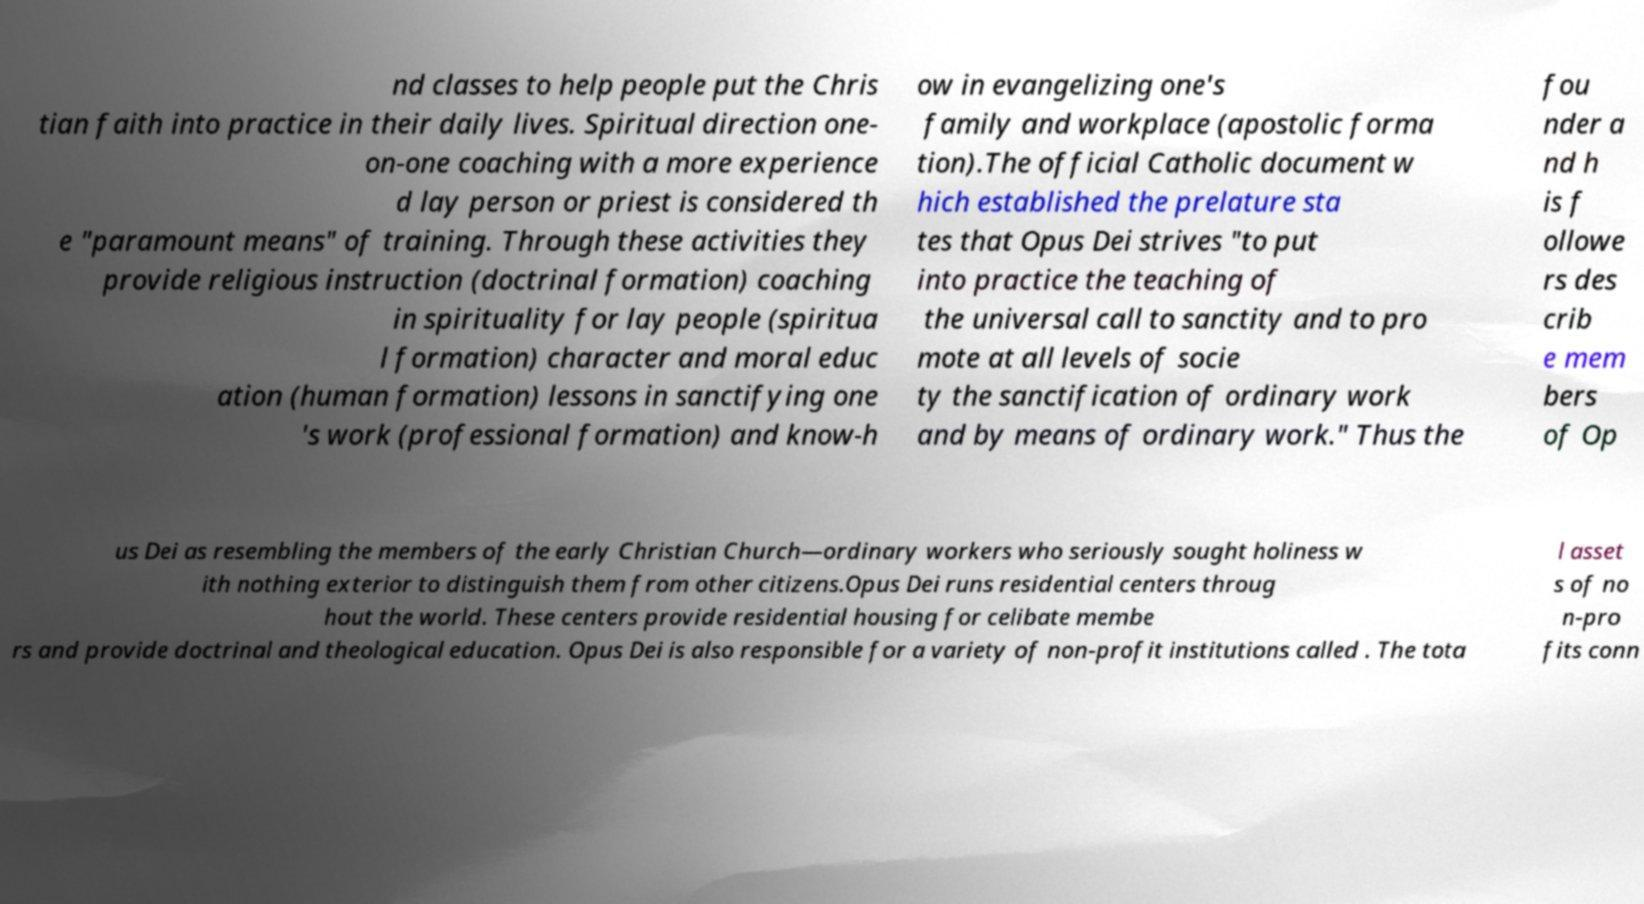For documentation purposes, I need the text within this image transcribed. Could you provide that? nd classes to help people put the Chris tian faith into practice in their daily lives. Spiritual direction one- on-one coaching with a more experience d lay person or priest is considered th e "paramount means" of training. Through these activities they provide religious instruction (doctrinal formation) coaching in spirituality for lay people (spiritua l formation) character and moral educ ation (human formation) lessons in sanctifying one 's work (professional formation) and know-h ow in evangelizing one's family and workplace (apostolic forma tion).The official Catholic document w hich established the prelature sta tes that Opus Dei strives "to put into practice the teaching of the universal call to sanctity and to pro mote at all levels of socie ty the sanctification of ordinary work and by means of ordinary work." Thus the fou nder a nd h is f ollowe rs des crib e mem bers of Op us Dei as resembling the members of the early Christian Church—ordinary workers who seriously sought holiness w ith nothing exterior to distinguish them from other citizens.Opus Dei runs residential centers throug hout the world. These centers provide residential housing for celibate membe rs and provide doctrinal and theological education. Opus Dei is also responsible for a variety of non-profit institutions called . The tota l asset s of no n-pro fits conn 